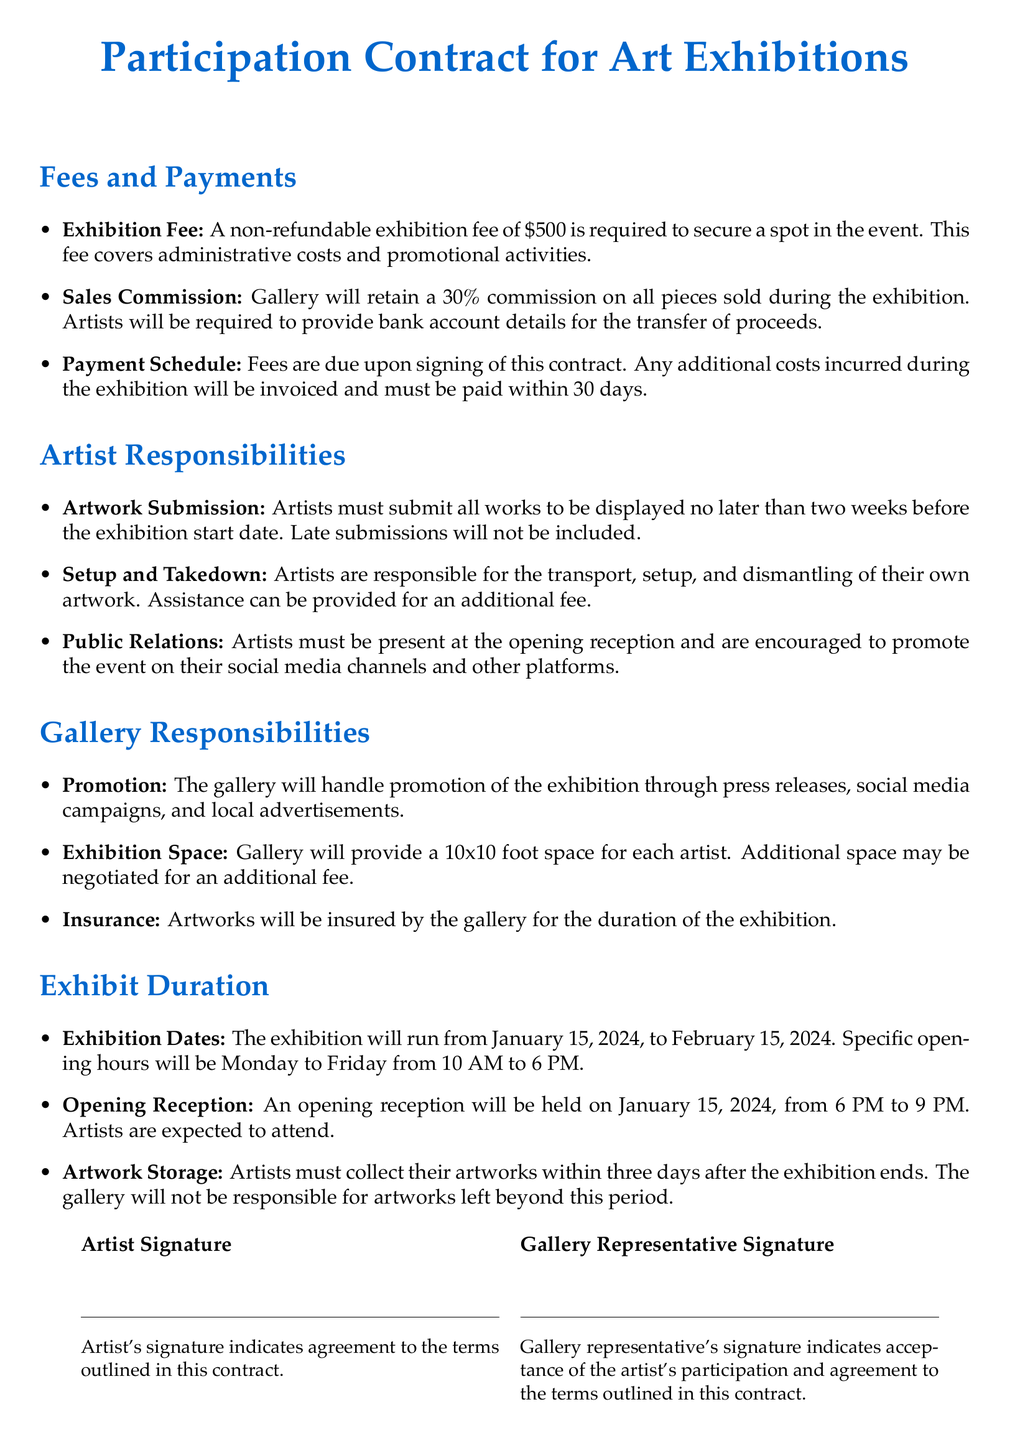What is the exhibition fee? The exhibition fee is stated as a non-refundable amount required to secure a spot in the event.
Answer: $500 What is the commission percentage the gallery retains from sales? The document specifies the percentage the gallery will keep from each sale made during the exhibition.
Answer: 30% When is the artwork submission deadline? The deadline for submitting artwork is two weeks before the exhibition starts, which is crucial for planning.
Answer: Two weeks before What are the exhibition dates? The document states the period during which the exhibition will take place.
Answer: January 15, 2024, to February 15, 2024 What is the required action after the exhibition ends? The artist needs to complete an important task concerning the artwork after the exhibition closes.
Answer: Collect artworks What is the gallery's responsibility regarding insurance? The section explains what the gallery will do to protect the artworks during the exhibition.
Answer: Insure artworks What time does the opening reception start? The document indicates the starting time for the public event where artists are expected to be present.
Answer: 6 PM What space size does the gallery provide for each artist? The document specifies the size of the display area allocated to each artist in the exhibition.
Answer: 10x10 foot What is the artist's responsibility concerning public relations? The artist must participate actively in promoting the event through attendance and social media.
Answer: Present at the opening reception 